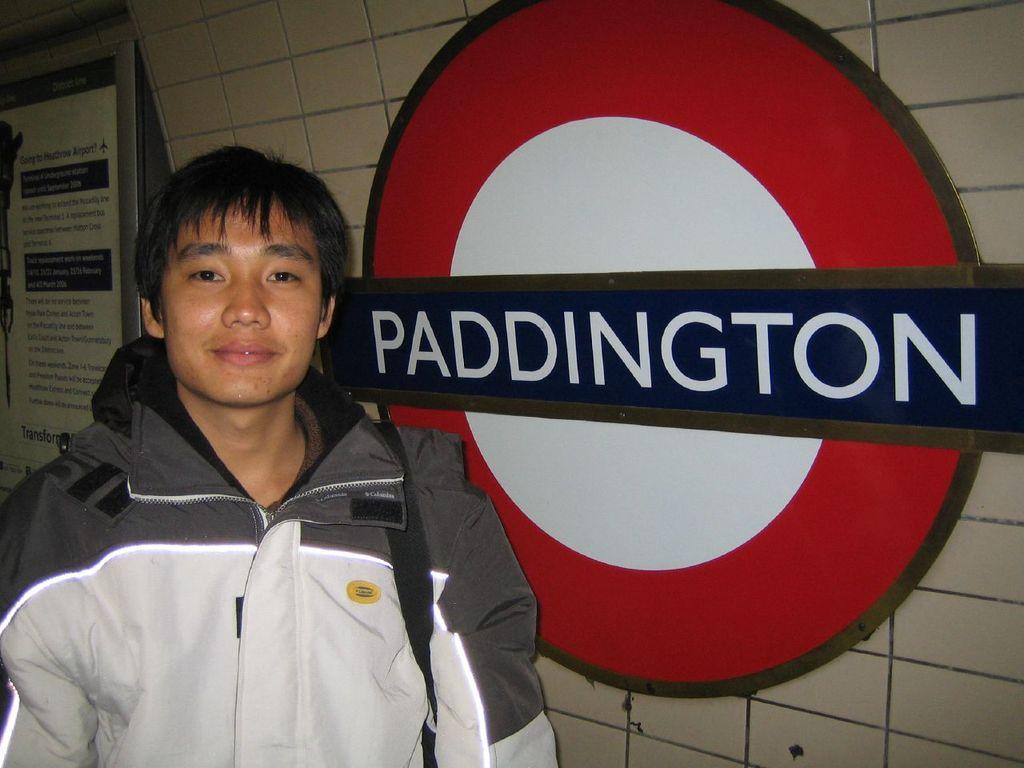<image>
Provide a brief description of the given image. a boy standing next to a sign that says Paddington on it 